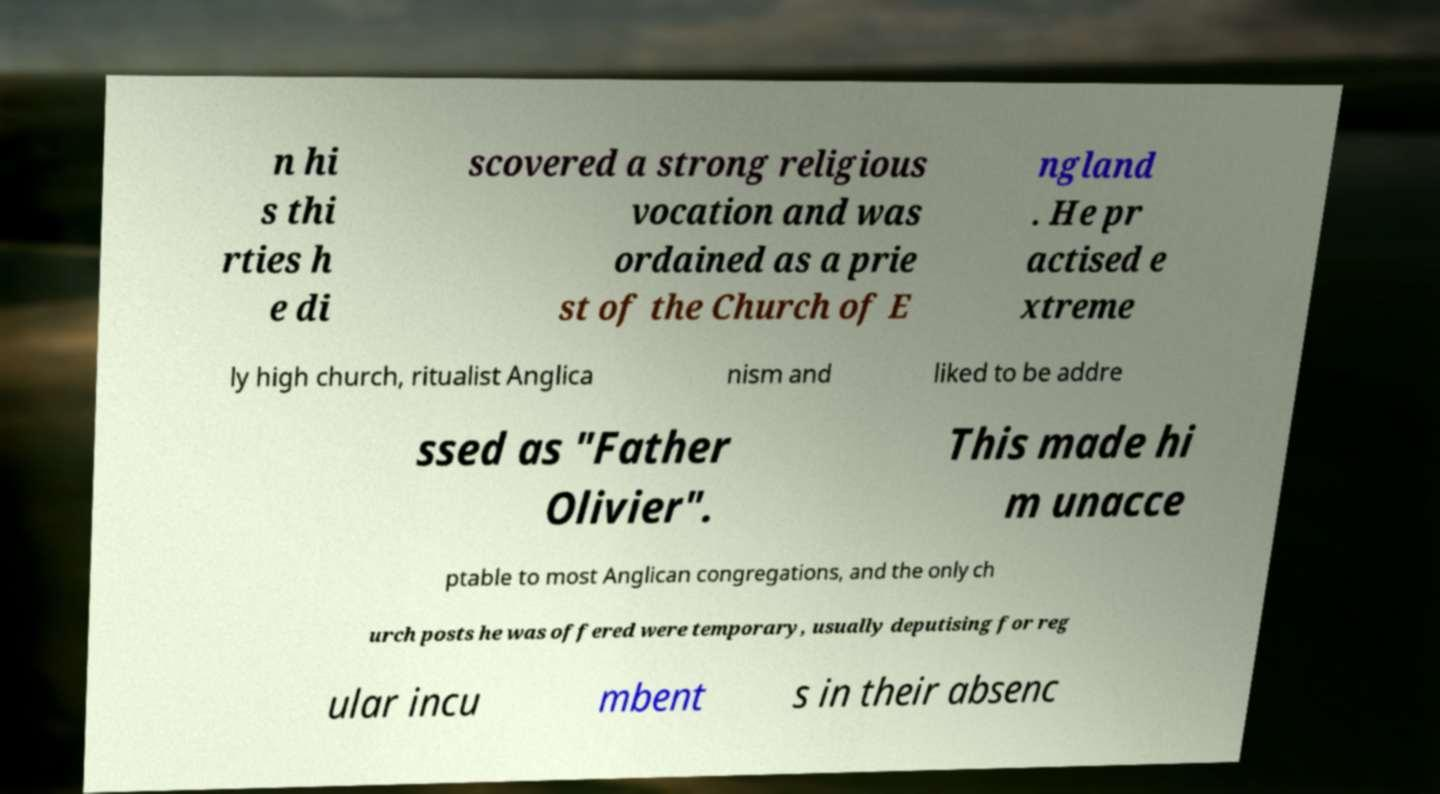Can you read and provide the text displayed in the image?This photo seems to have some interesting text. Can you extract and type it out for me? n hi s thi rties h e di scovered a strong religious vocation and was ordained as a prie st of the Church of E ngland . He pr actised e xtreme ly high church, ritualist Anglica nism and liked to be addre ssed as "Father Olivier". This made hi m unacce ptable to most Anglican congregations, and the only ch urch posts he was offered were temporary, usually deputising for reg ular incu mbent s in their absenc 